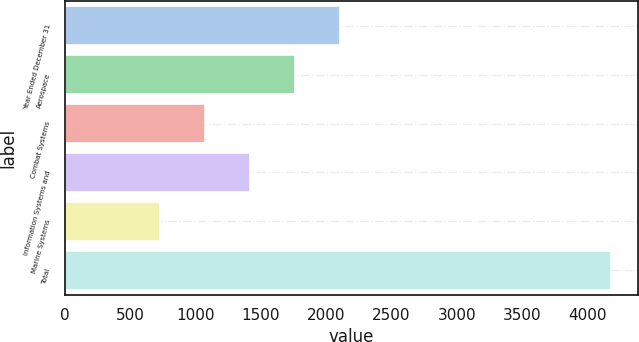Convert chart. <chart><loc_0><loc_0><loc_500><loc_500><bar_chart><fcel>Year Ended December 31<fcel>Aerospace<fcel>Combat Systems<fcel>Information Systems and<fcel>Marine Systems<fcel>Total<nl><fcel>2108<fcel>1763<fcel>1073<fcel>1418<fcel>728<fcel>4178<nl></chart> 